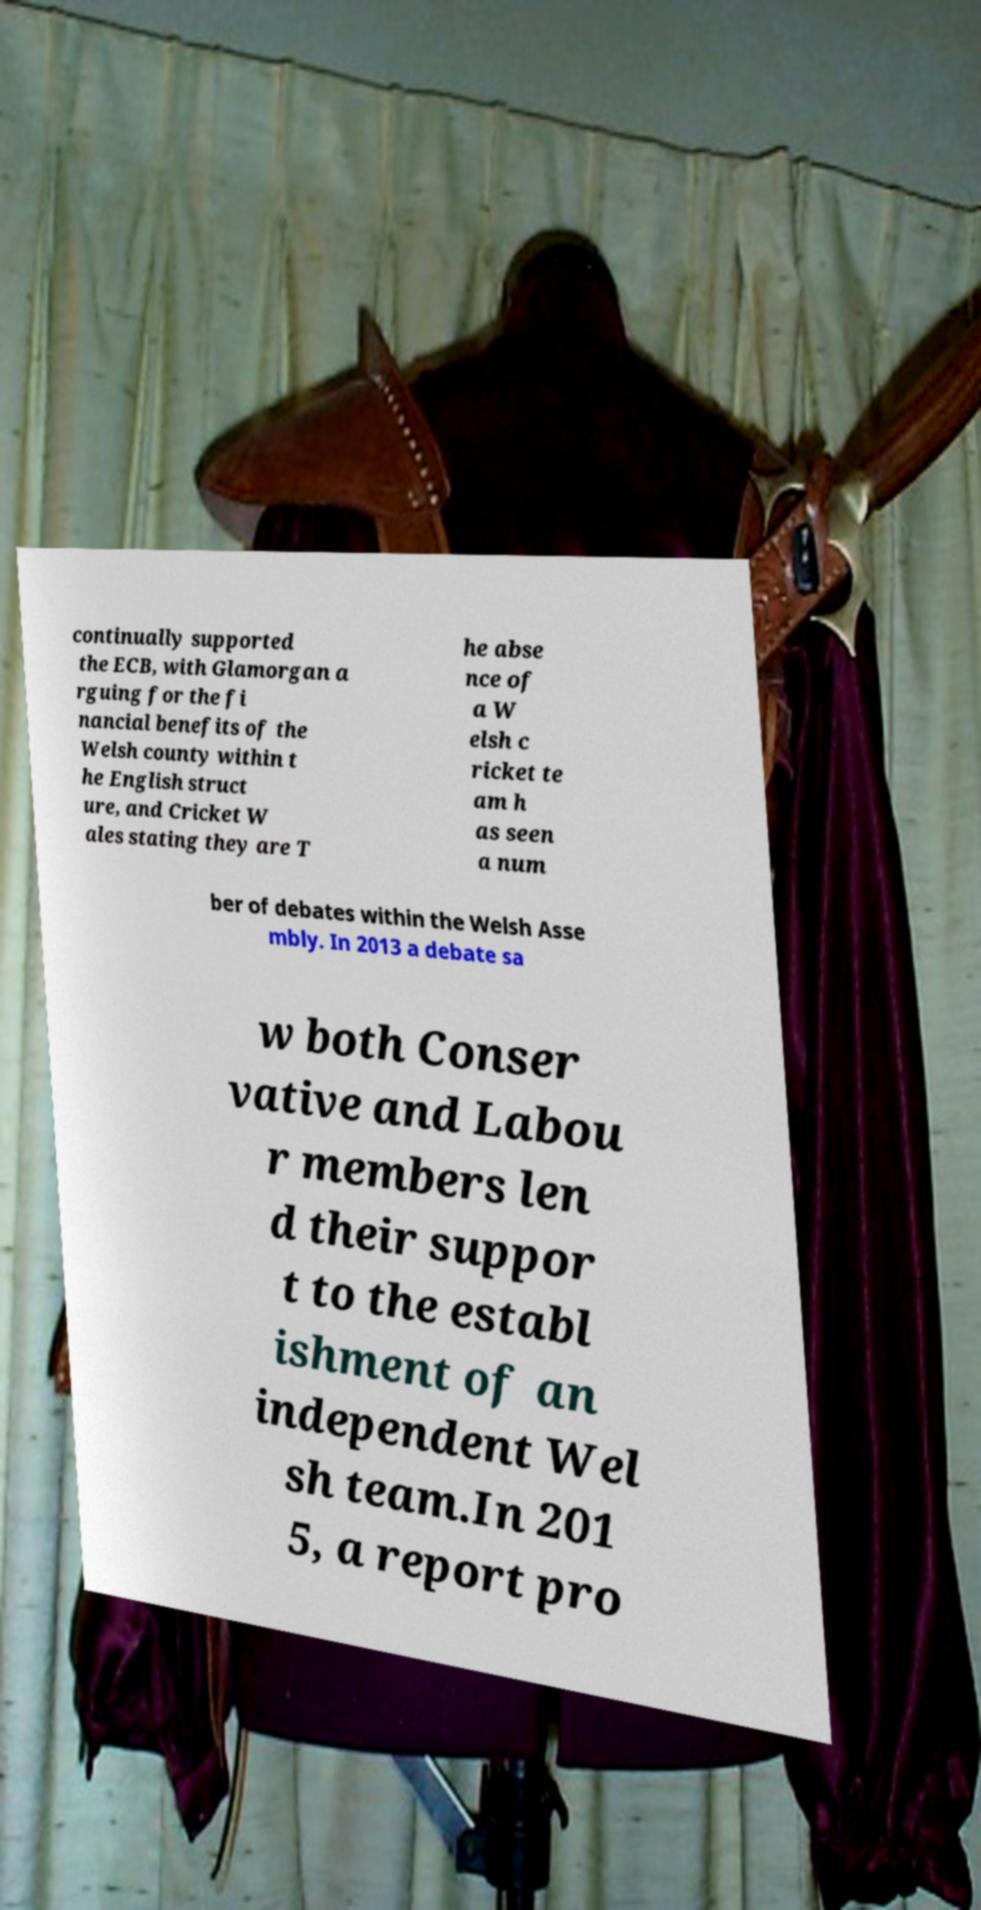Could you extract and type out the text from this image? continually supported the ECB, with Glamorgan a rguing for the fi nancial benefits of the Welsh county within t he English struct ure, and Cricket W ales stating they are T he abse nce of a W elsh c ricket te am h as seen a num ber of debates within the Welsh Asse mbly. In 2013 a debate sa w both Conser vative and Labou r members len d their suppor t to the establ ishment of an independent Wel sh team.In 201 5, a report pro 